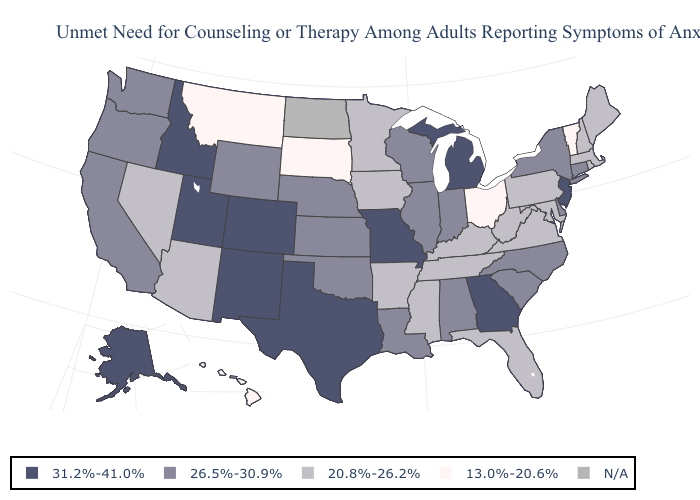Which states have the lowest value in the USA?
Answer briefly. Hawaii, Montana, Ohio, South Dakota, Vermont. What is the value of Ohio?
Answer briefly. 13.0%-20.6%. Name the states that have a value in the range N/A?
Short answer required. North Dakota. What is the lowest value in the South?
Concise answer only. 20.8%-26.2%. Among the states that border Virginia , does North Carolina have the highest value?
Keep it brief. Yes. Name the states that have a value in the range 13.0%-20.6%?
Concise answer only. Hawaii, Montana, Ohio, South Dakota, Vermont. Name the states that have a value in the range 20.8%-26.2%?
Keep it brief. Arizona, Arkansas, Florida, Iowa, Kentucky, Maine, Maryland, Massachusetts, Minnesota, Mississippi, Nevada, New Hampshire, Pennsylvania, Rhode Island, Tennessee, Virginia, West Virginia. Does Montana have the lowest value in the USA?
Keep it brief. Yes. Which states have the lowest value in the Northeast?
Be succinct. Vermont. Which states have the highest value in the USA?
Answer briefly. Alaska, Colorado, Georgia, Idaho, Michigan, Missouri, New Jersey, New Mexico, Texas, Utah. What is the highest value in the South ?
Concise answer only. 31.2%-41.0%. Name the states that have a value in the range N/A?
Answer briefly. North Dakota. Does the first symbol in the legend represent the smallest category?
Answer briefly. No. 